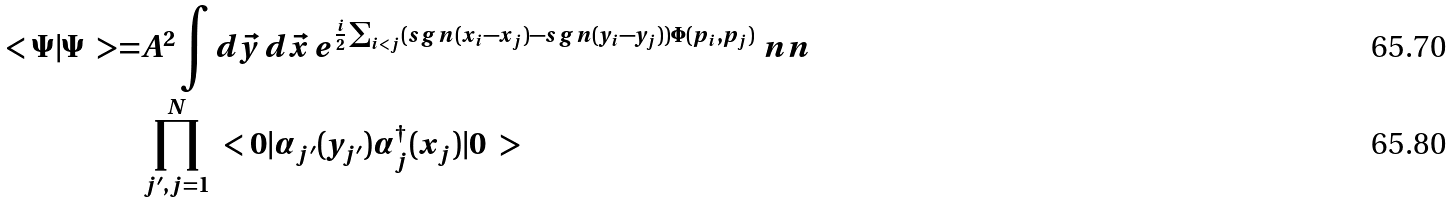Convert formula to latex. <formula><loc_0><loc_0><loc_500><loc_500>\ < \Psi | \Psi \ > = & A ^ { 2 } \int d \vec { y } \, d \vec { x } \, e ^ { \frac { i } { 2 } \sum _ { i < j } ( s g n ( x _ { i } - x _ { j } ) - s g n ( y _ { i } - y _ { j } ) ) \Phi ( p _ { i } , p _ { j } ) } \ n n \\ & \prod _ { j ^ { \prime } , j = 1 } ^ { N } \ < 0 | \alpha _ { j ^ { \prime } } ( y _ { j ^ { \prime } } ) \alpha _ { j } ^ { \dagger } ( x _ { j } ) | 0 \ ></formula> 